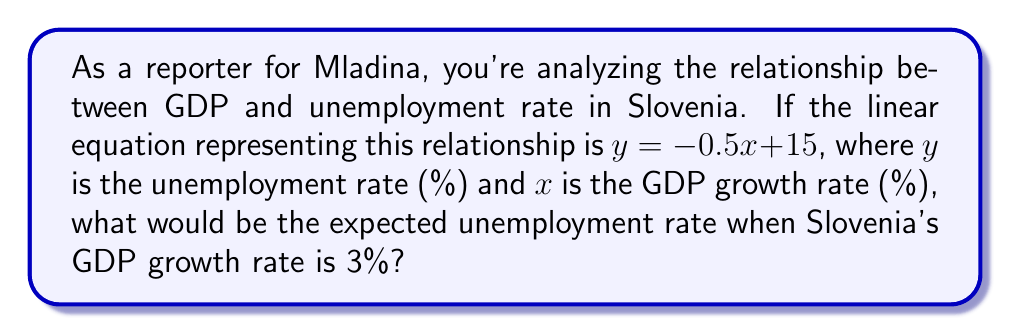What is the answer to this math problem? To solve this problem, we'll follow these steps:

1. Understand the given equation:
   $y = -0.5x + 15$
   Where:
   $y$ = unemployment rate (%)
   $x$ = GDP growth rate (%)

2. We're asked to find the unemployment rate when the GDP growth rate is 3%.
   So, we need to substitute $x = 3$ into the equation.

3. Let's calculate:
   $y = -0.5(3) + 15$
   $y = -1.5 + 15$
   $y = 13.5$

4. Interpret the result:
   When Slovenia's GDP growth rate is 3%, the expected unemployment rate would be 13.5%.

Note: This linear relationship suggests that as GDP growth increases, unemployment tends to decrease, which is a common economic phenomenon.
Answer: 13.5% 